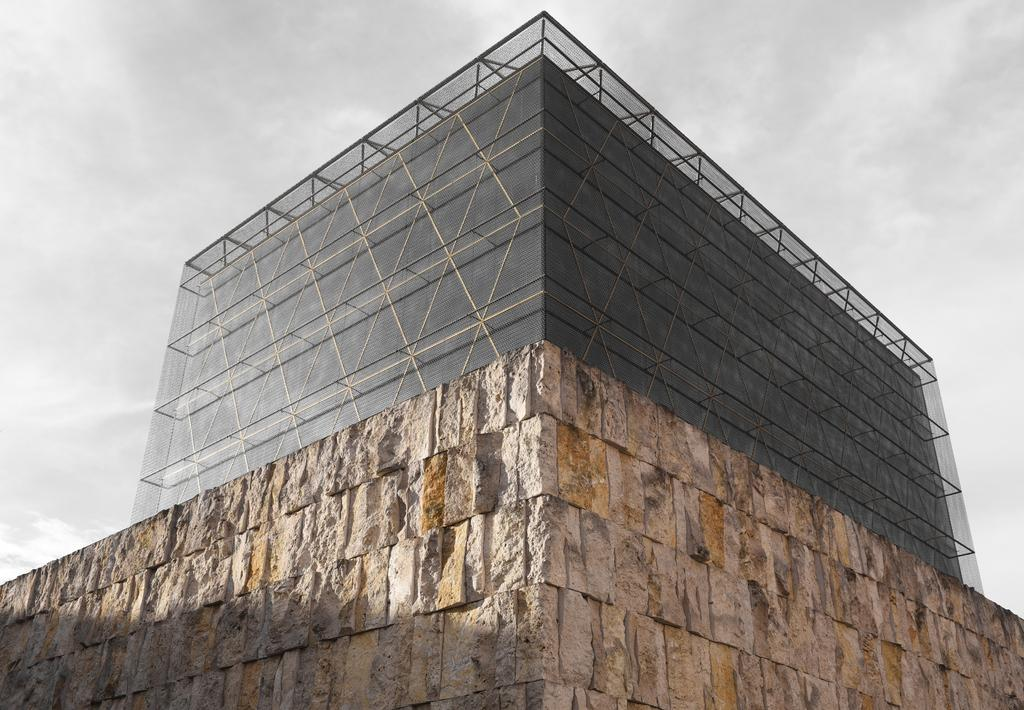What type of structure is located at the bottom of the image? There is a stonewall at the down side of the image. What other type of structure can be seen in the image? There is a glass building in the image. What is visible at the top of the image? The sky is visible at the top of the image. What is the condition of the sky in the image? The sky is cloudy in the image. How many rings does the beginner wear in the image? There are no rings or beginners present in the image. What step is being taken by the person in the image? There is no person or step visible in the image. 